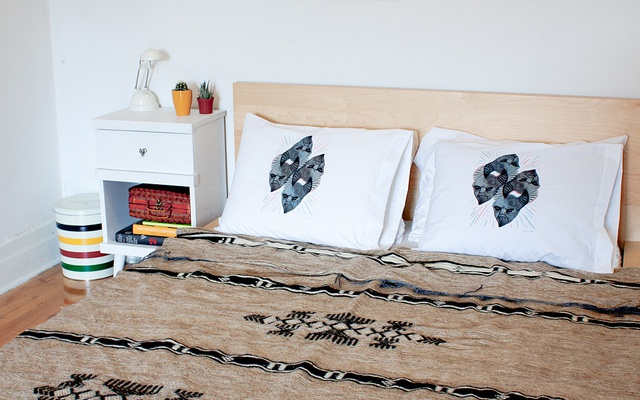Describe the objects in this image and their specific colors. I can see bed in lightgray, darkgray, and gray tones, potted plant in lightgray, orange, and black tones, potted plant in lightgray, brown, darkgray, gray, and maroon tones, book in lightgray, black, gray, blue, and navy tones, and book in lightgray, orange, and tan tones in this image. 